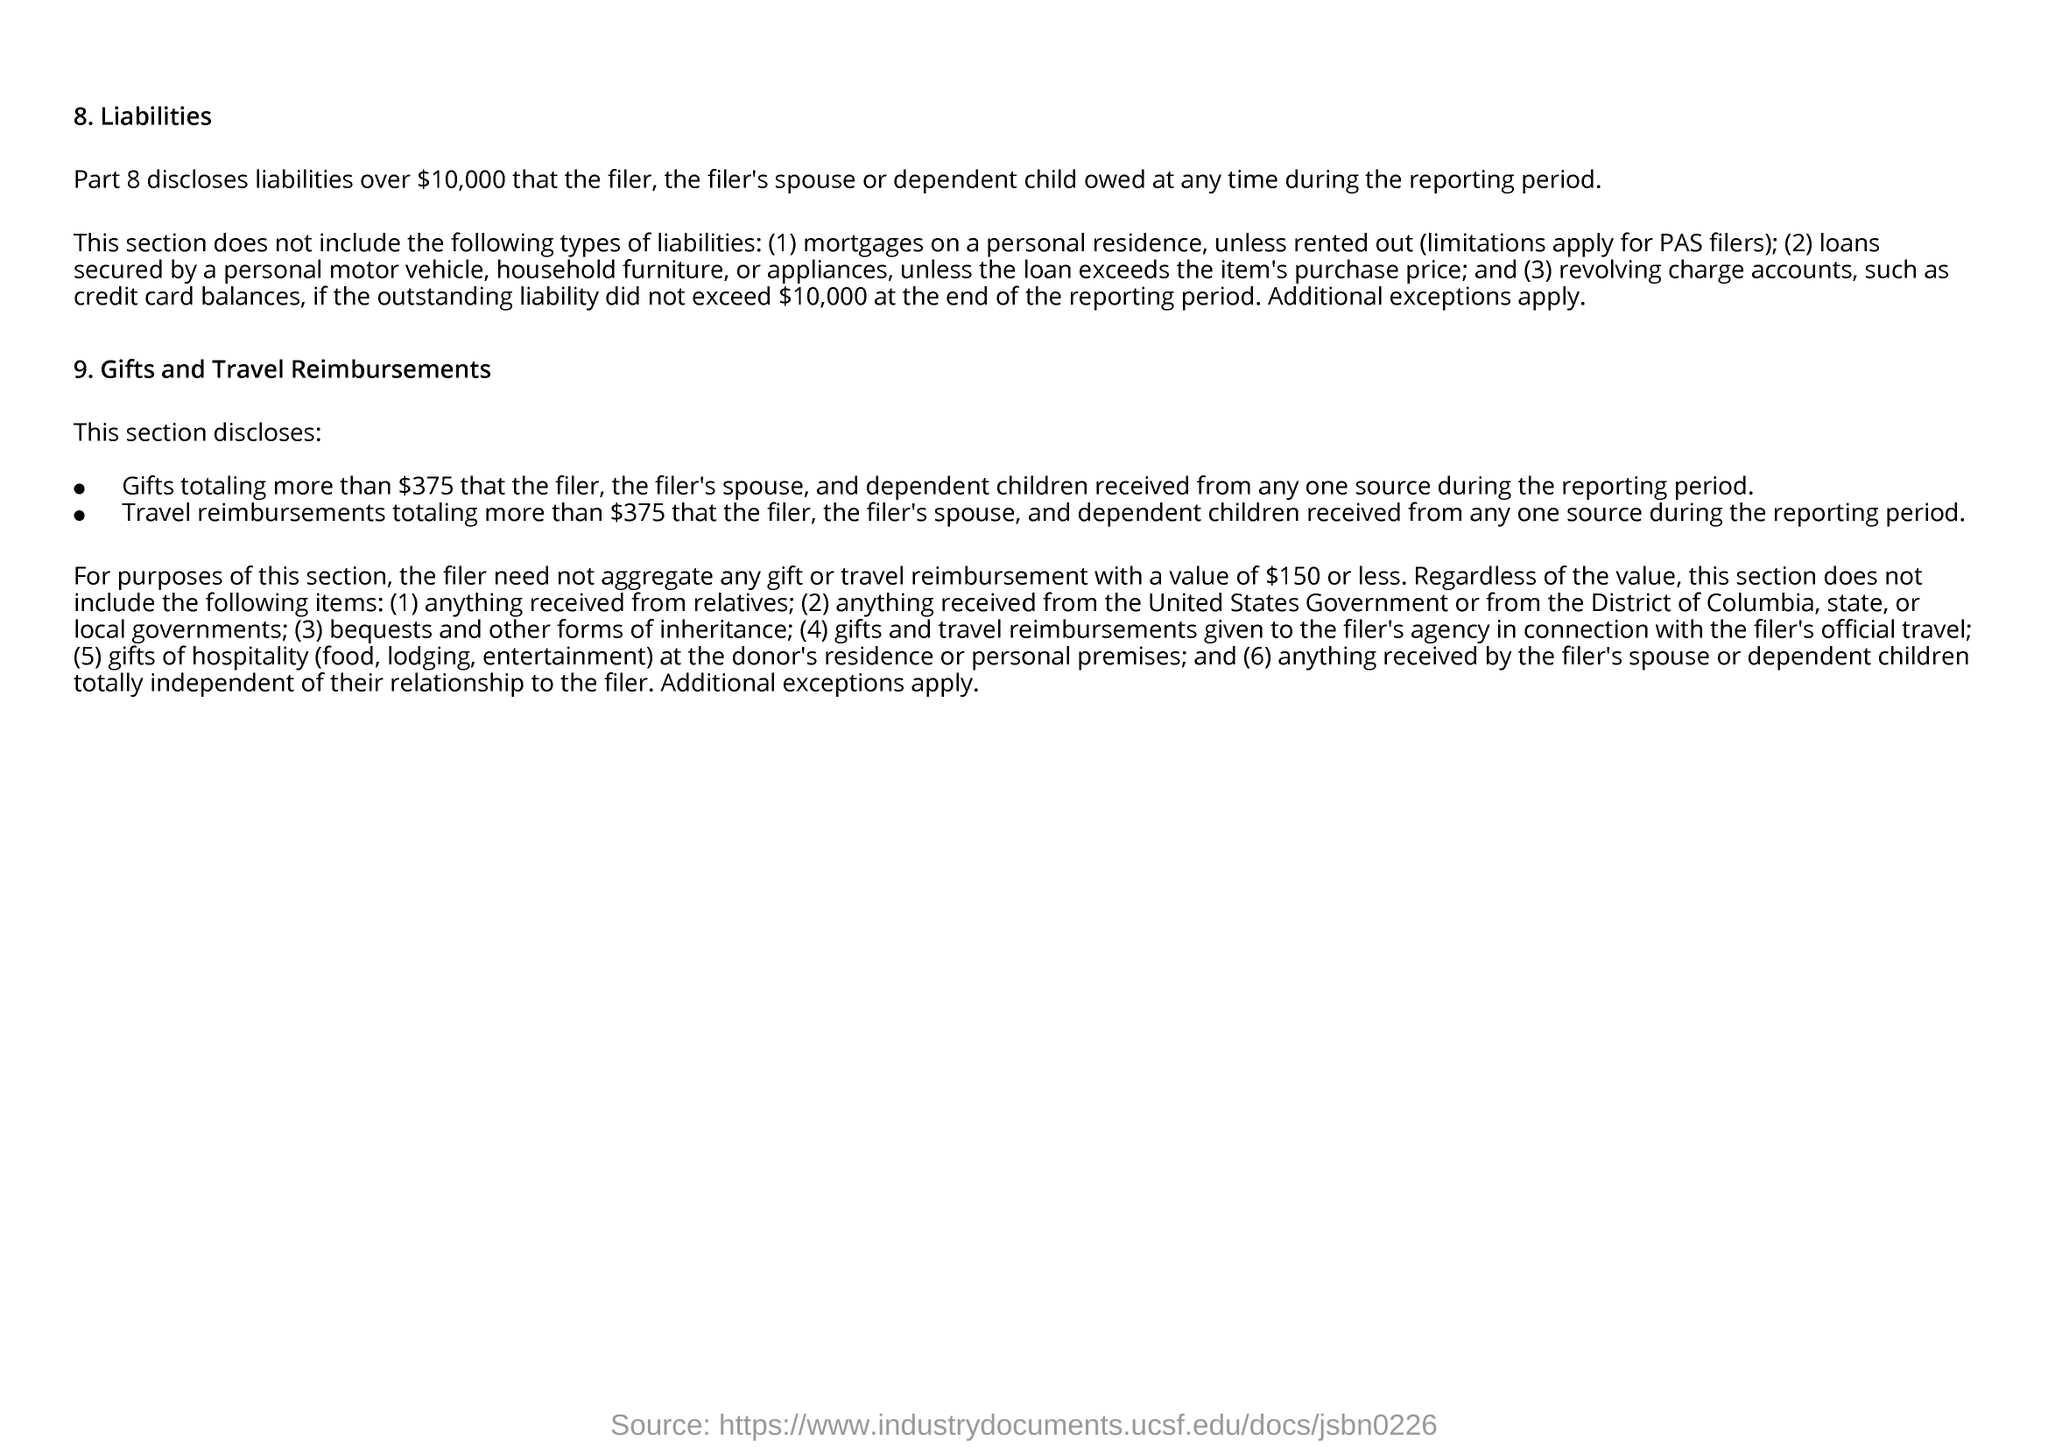Indicate a few pertinent items in this graphic. The first title in the document is 'Liabilities.' 